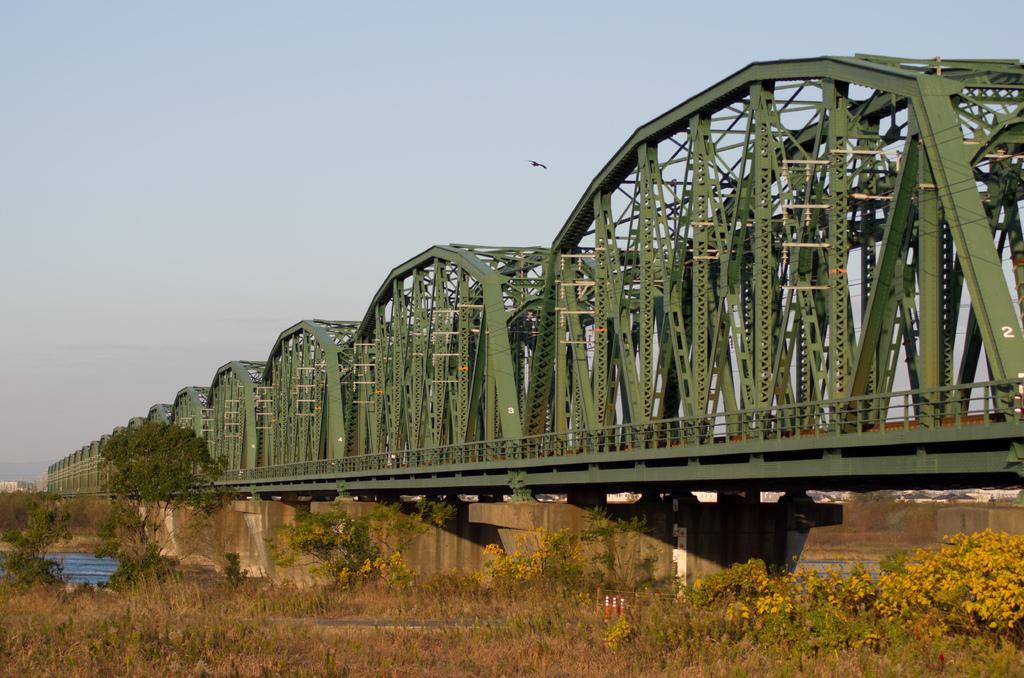Describe this image in one or two sentences. In this image, we can see some plants and trees. There is a bridge in the middle of the image. At the top of the image, we can see the sky. 